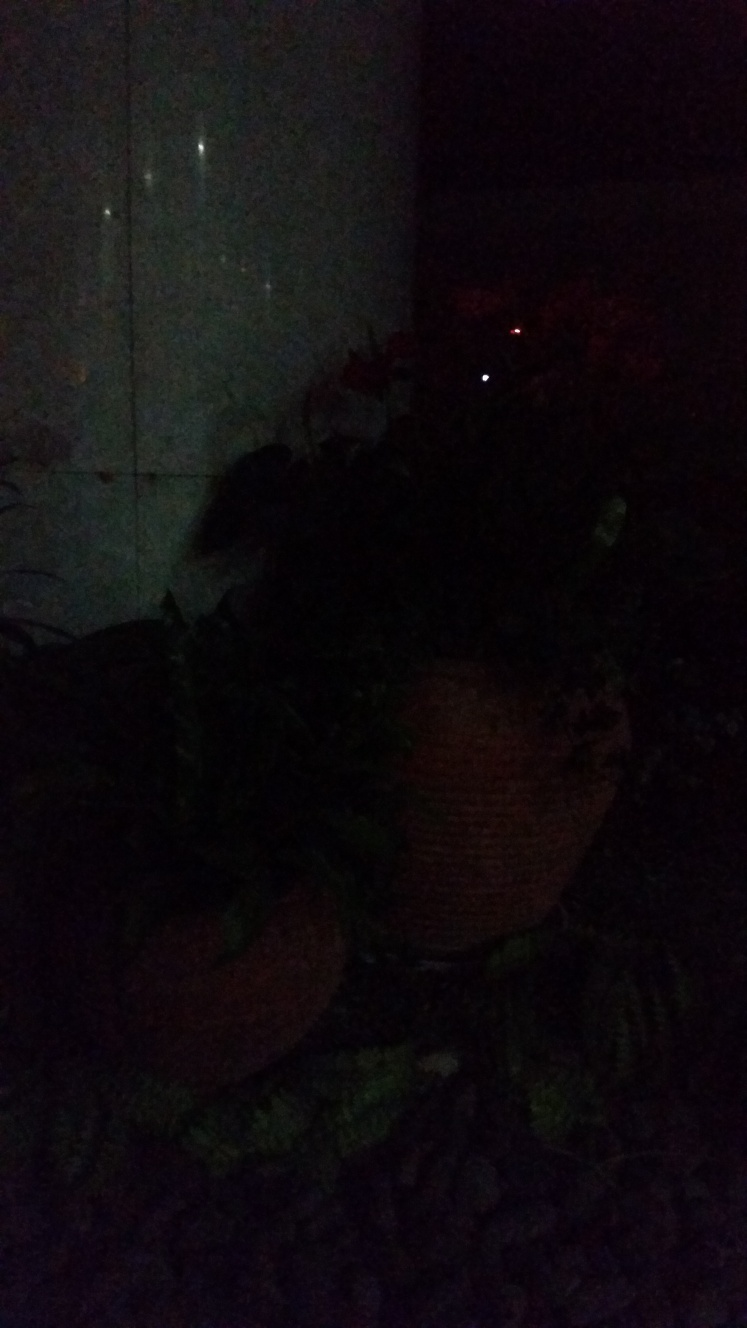What kind of plants can you identify in the image? Due to the very low light in the image, it's difficult to identify specific types of plants. To make an accurate identification, an image with better lighting would be required. If this is a garden, what time would be best for taking a photo to capture its details? The best time for taking photos of a garden to capture ample detail would be during the day, particularly in the early morning or late afternoon when the sunlight provides a warm, natural light without being overly harsh. 